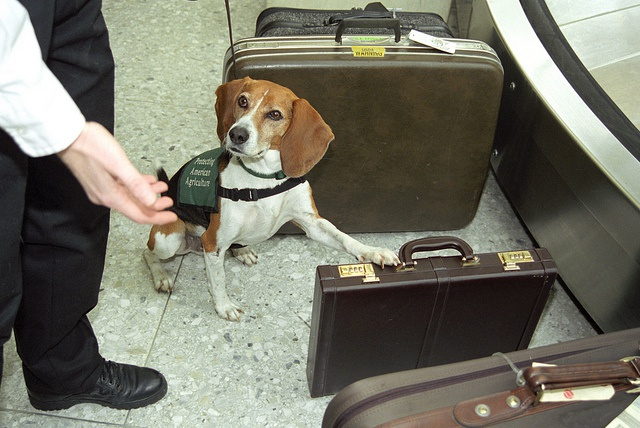Describe the objects in this image and their specific colors. I can see people in white, black, and tan tones, suitcase in white, black, and gray tones, suitcase in white, black, and gray tones, dog in white, beige, black, darkgray, and tan tones, and suitcase in white, gray, and maroon tones in this image. 